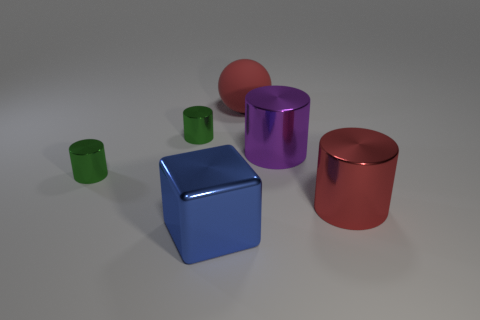Subtract all yellow balls. Subtract all cyan blocks. How many balls are left? 1 Add 4 big blue objects. How many objects exist? 10 Subtract all balls. How many objects are left? 5 Add 1 big red things. How many big red things exist? 3 Subtract 1 purple cylinders. How many objects are left? 5 Subtract all purple metal things. Subtract all cylinders. How many objects are left? 1 Add 5 blue metallic cubes. How many blue metallic cubes are left? 6 